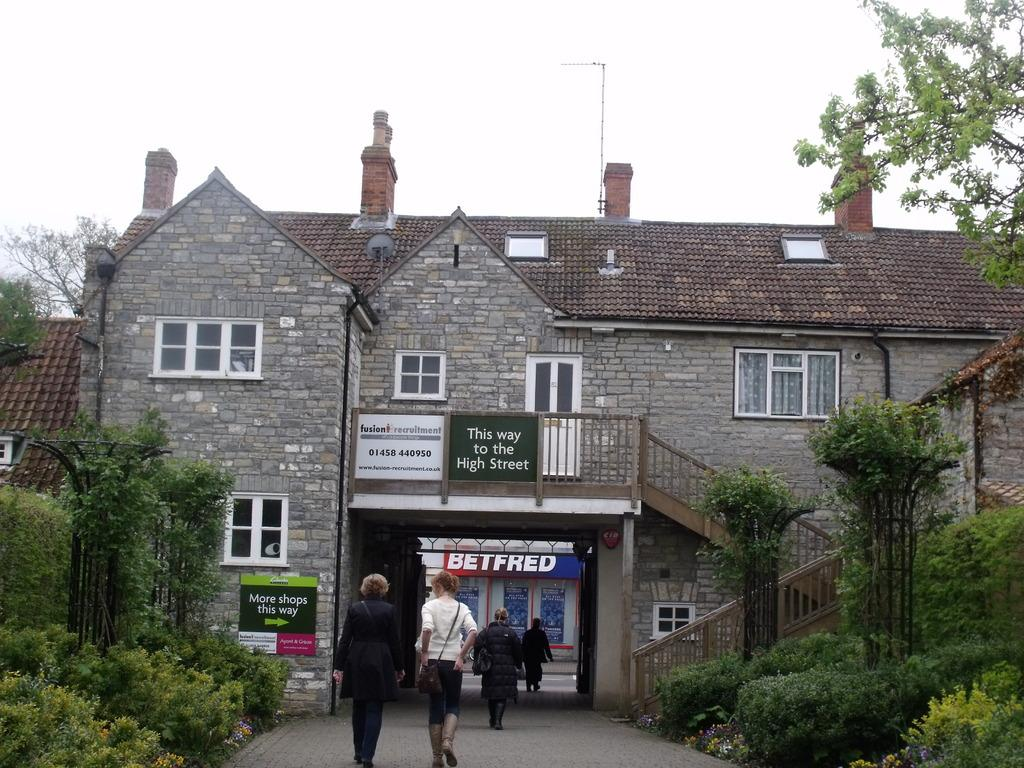What type of house is shown in the image? There is a house made of bricks in the image. What can be seen outside the house? There are trees visible outside the house. What activity is happening on the road in the image? People are walking on the road in the image. How many eyes can be seen on the trail in the image? There is no trail present in the image, and therefore no eyes can be seen on it. 